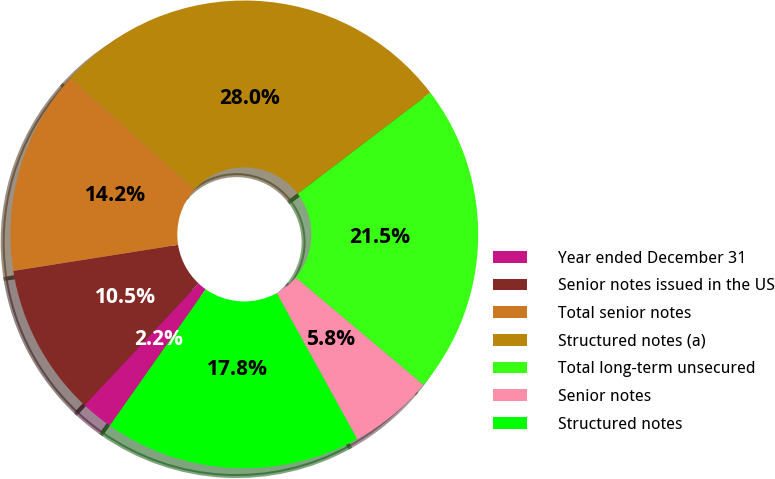Convert chart. <chart><loc_0><loc_0><loc_500><loc_500><pie_chart><fcel>Year ended December 31<fcel>Senior notes issued in the US<fcel>Total senior notes<fcel>Structured notes (a)<fcel>Total long-term unsecured<fcel>Senior notes<fcel>Structured notes<nl><fcel>2.22%<fcel>10.53%<fcel>14.16%<fcel>27.98%<fcel>21.49%<fcel>5.85%<fcel>17.78%<nl></chart> 